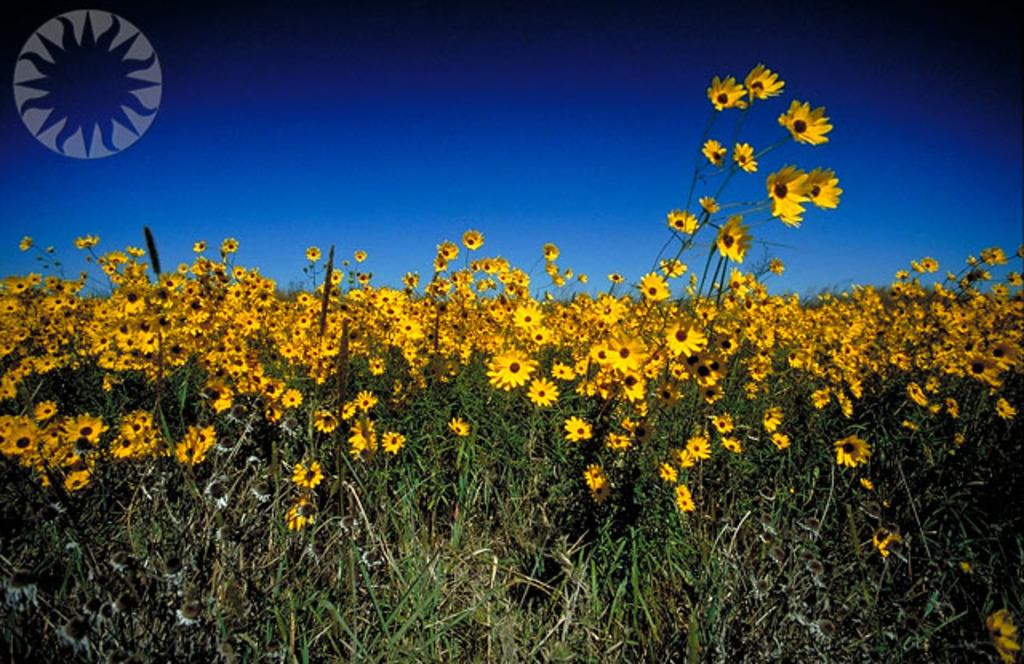What type of plants are present in the image? There are plants with flowers in the image. What can be seen in the background of the image? The sky is visible at the top of the image. Is there any text or symbol present in the image? Yes, there is a logo in the image. Can you tell me how deep the river is in the image? There is no river present in the image; it features plants with flowers and a visible sky. 